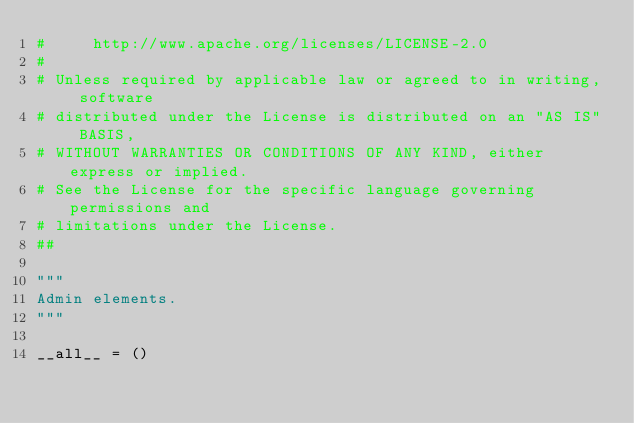Convert code to text. <code><loc_0><loc_0><loc_500><loc_500><_Python_>#     http://www.apache.org/licenses/LICENSE-2.0
#
# Unless required by applicable law or agreed to in writing, software
# distributed under the License is distributed on an "AS IS" BASIS,
# WITHOUT WARRANTIES OR CONDITIONS OF ANY KIND, either express or implied.
# See the License for the specific language governing permissions and
# limitations under the License.
##

"""
Admin elements.
"""

__all__ = ()
</code> 